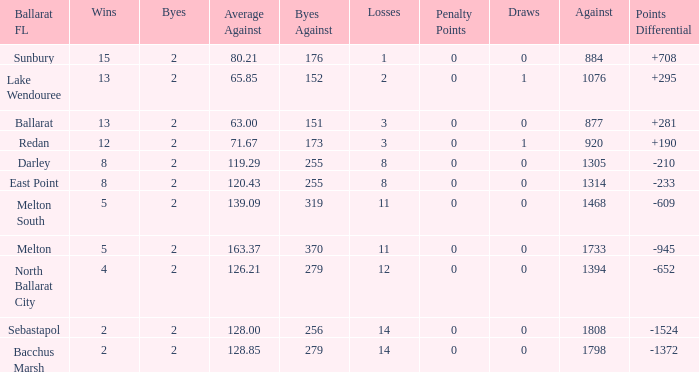How many Losses have a Ballarat FL of melton south, and an Against larger than 1468? 0.0. 